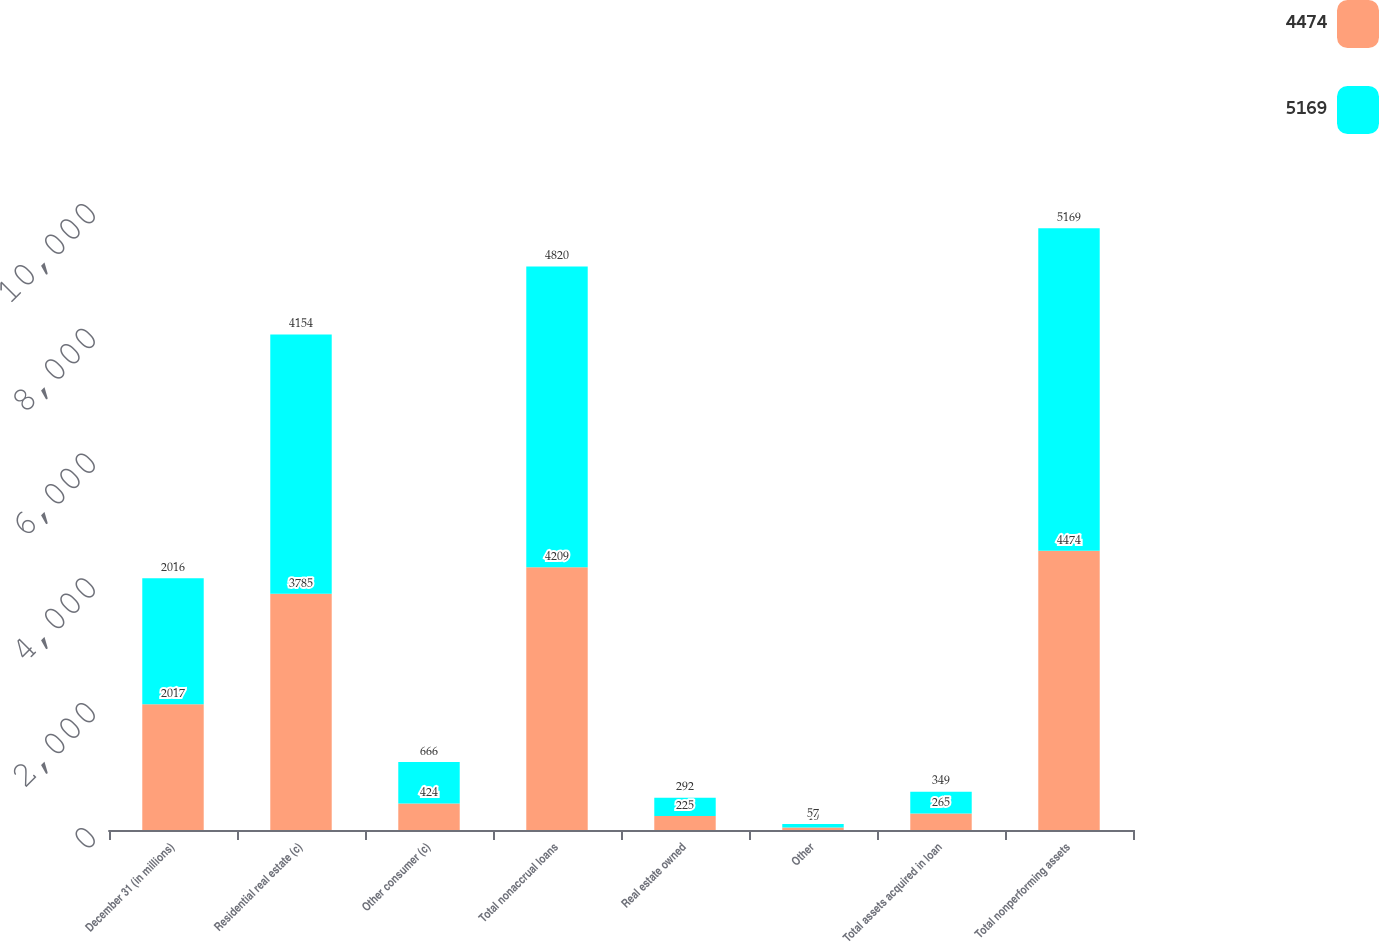Convert chart. <chart><loc_0><loc_0><loc_500><loc_500><stacked_bar_chart><ecel><fcel>December 31 (in millions)<fcel>Residential real estate (c)<fcel>Other consumer (c)<fcel>Total nonaccrual loans<fcel>Real estate owned<fcel>Other<fcel>Total assets acquired in loan<fcel>Total nonperforming assets<nl><fcel>4474<fcel>2017<fcel>3785<fcel>424<fcel>4209<fcel>225<fcel>40<fcel>265<fcel>4474<nl><fcel>5169<fcel>2016<fcel>4154<fcel>666<fcel>4820<fcel>292<fcel>57<fcel>349<fcel>5169<nl></chart> 